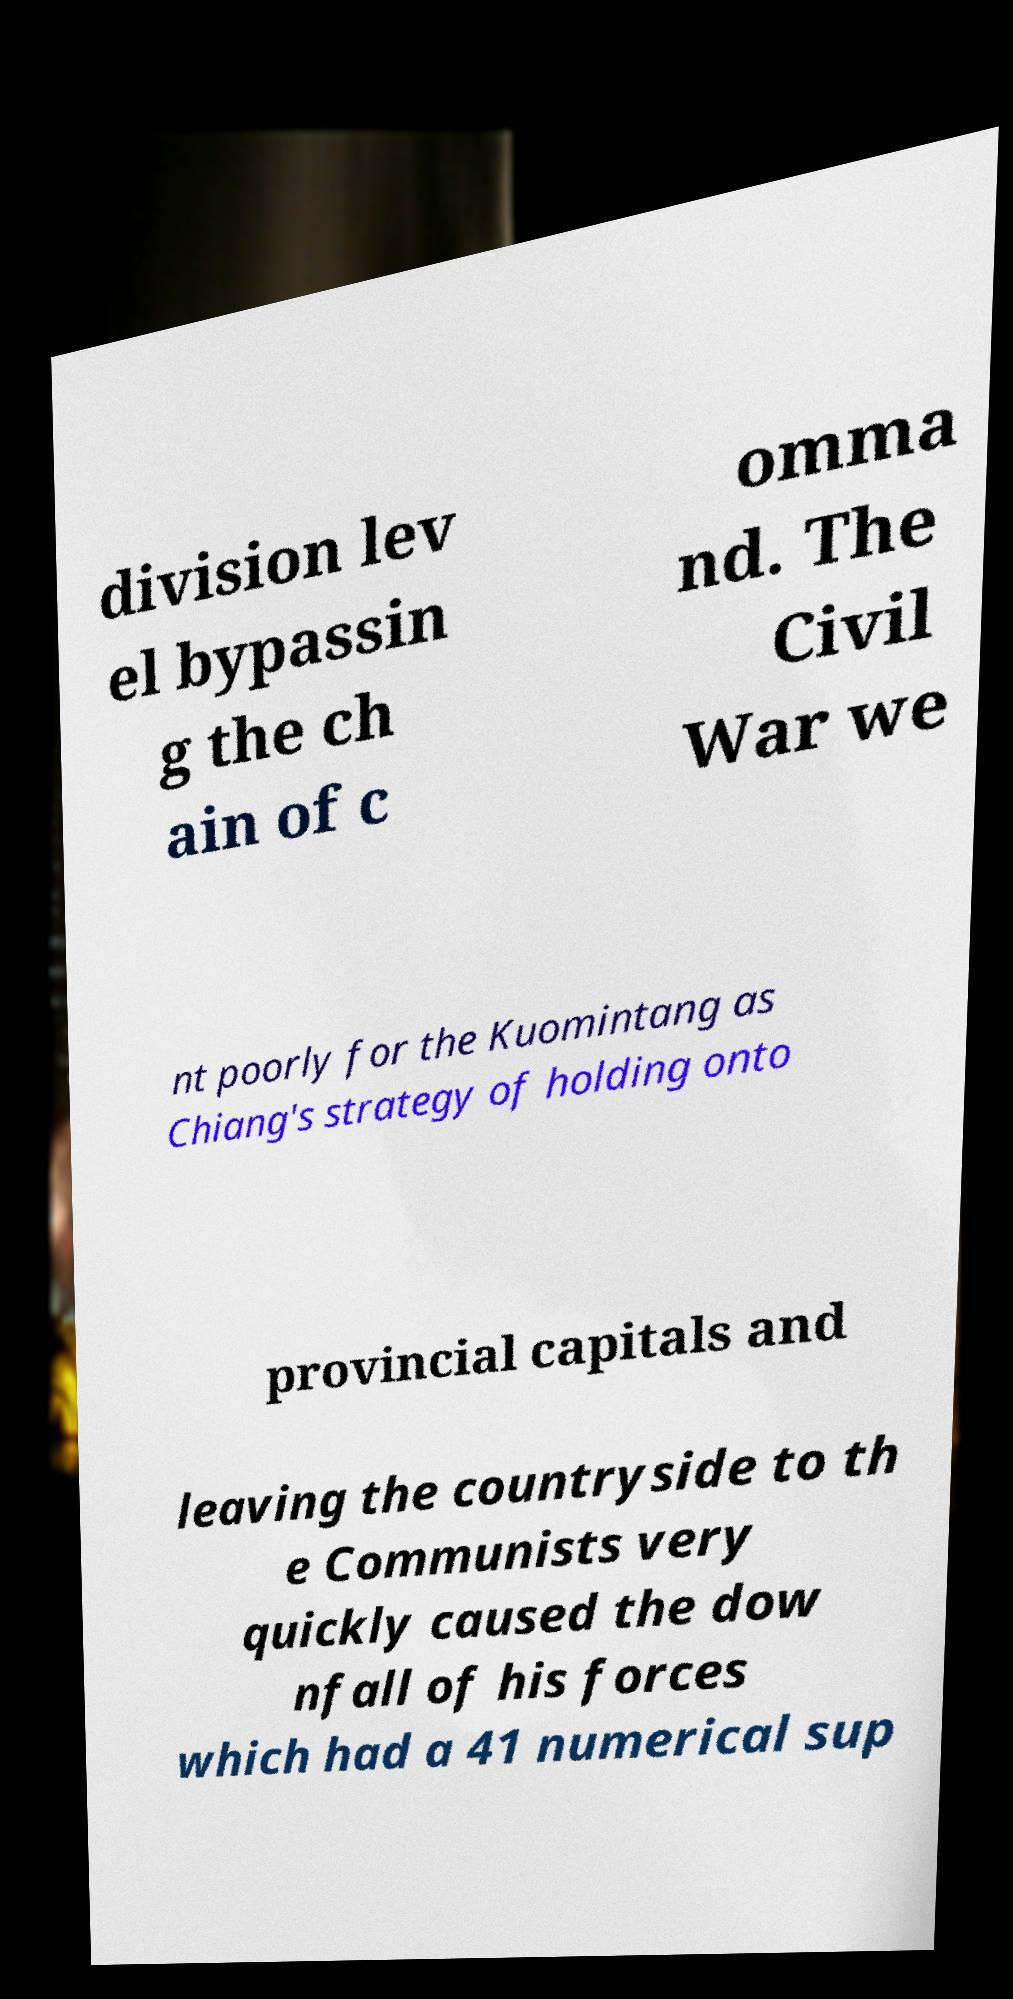Could you assist in decoding the text presented in this image and type it out clearly? division lev el bypassin g the ch ain of c omma nd. The Civil War we nt poorly for the Kuomintang as Chiang's strategy of holding onto provincial capitals and leaving the countryside to th e Communists very quickly caused the dow nfall of his forces which had a 41 numerical sup 